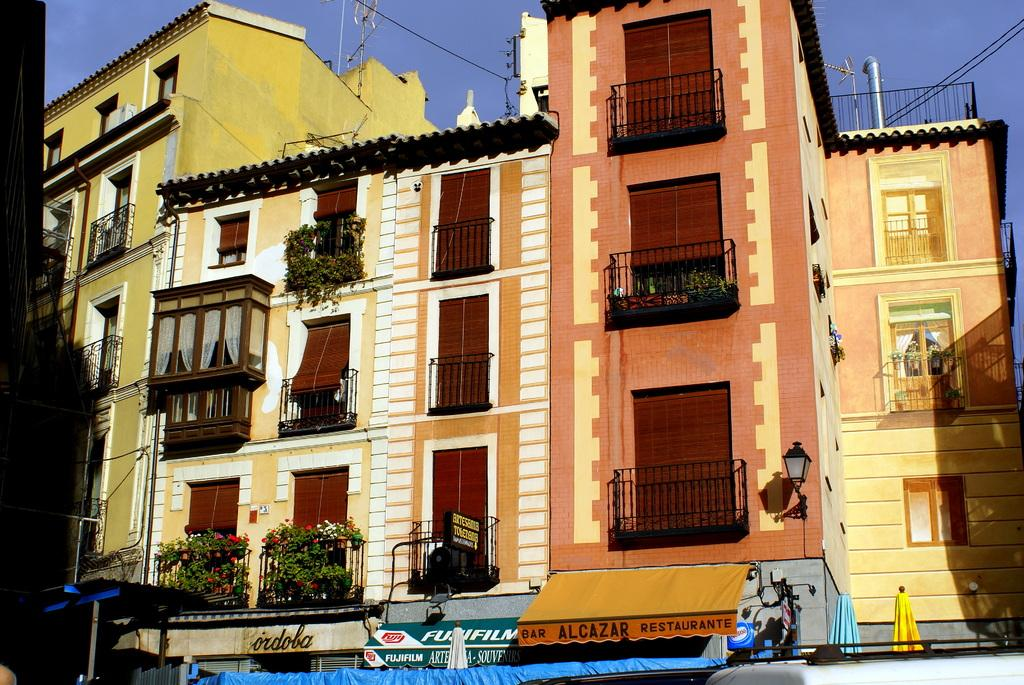What type of structure is present in the image? There is a building in the image. What feature can be seen on the building? The building has windows. What is located beneath the building? There are shop boards visible under the building. What can be seen from the top of the building? The sky is visible from the top of the building. How many minutes does it take for the wool to grow on the beast in the image? There is no wool or beast present in the image, so it is not possible to answer that question. 